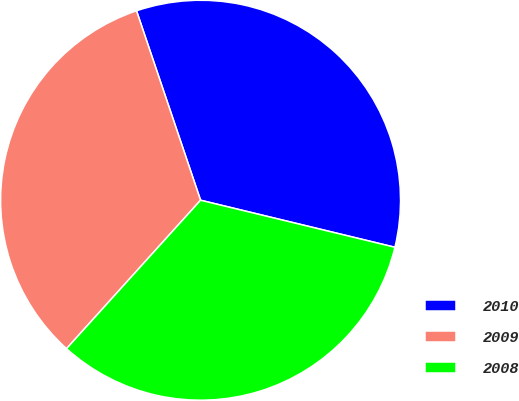<chart> <loc_0><loc_0><loc_500><loc_500><pie_chart><fcel>2010<fcel>2009<fcel>2008<nl><fcel>33.97%<fcel>33.12%<fcel>32.91%<nl></chart> 